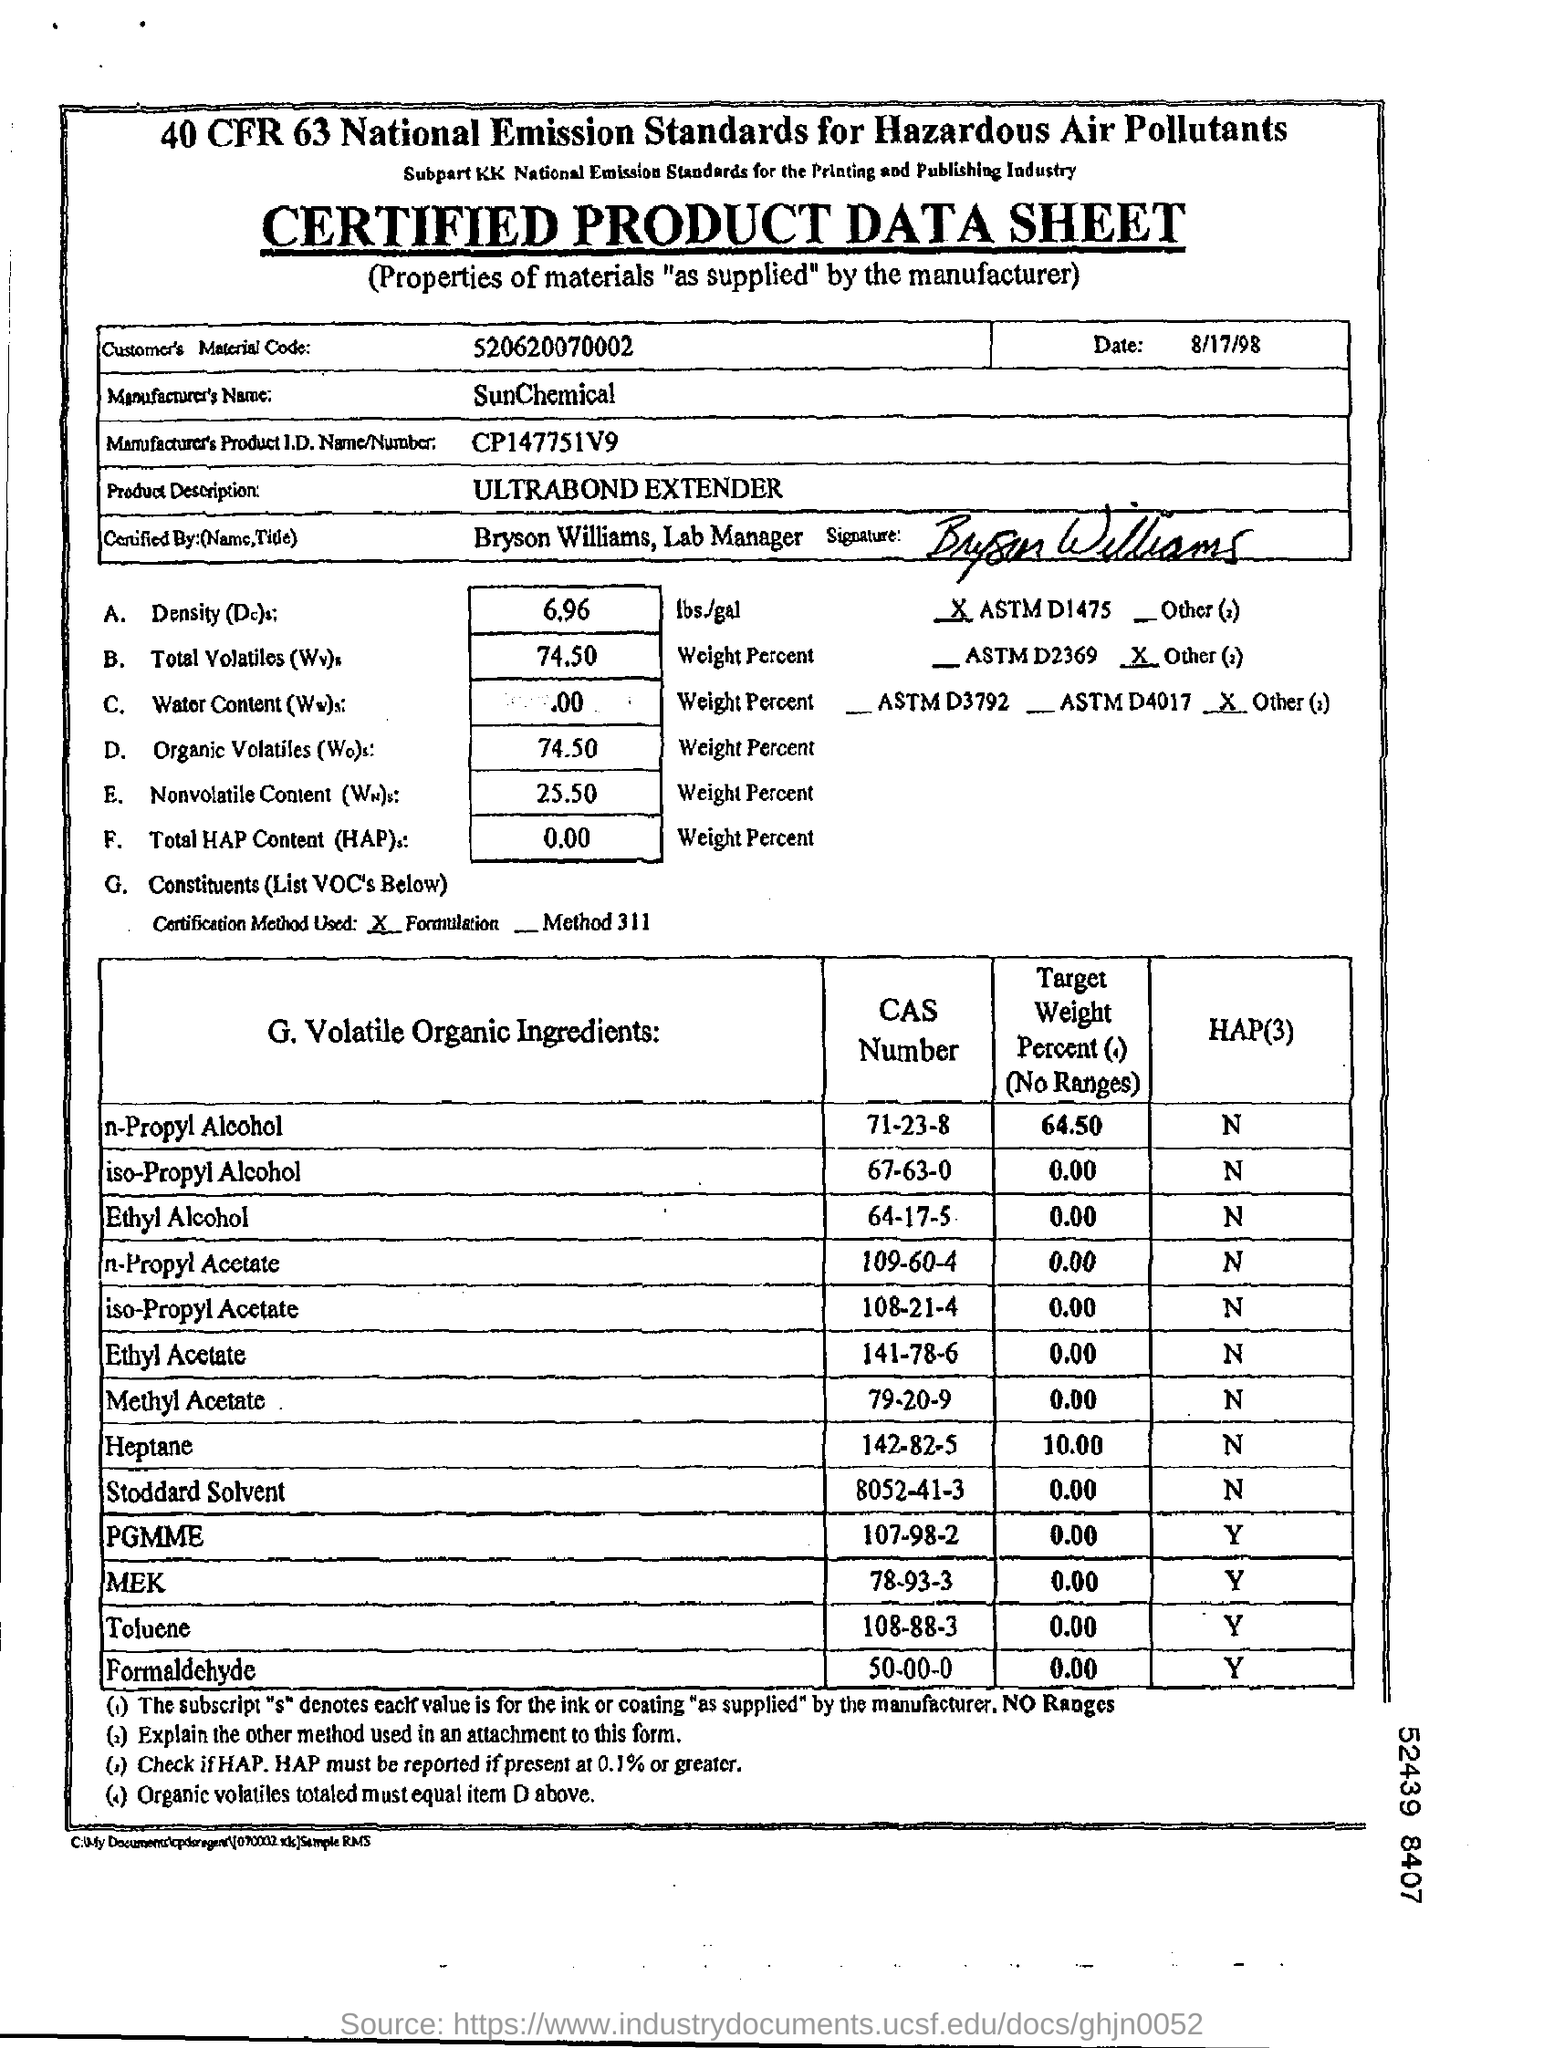Specify some key components in this picture. Ethyl alcohol, also known as grain alcohol or ethanol, has a CAS number of 64-17-5. The manufacturer's product identification number is CP147751V9. What is the name of the sheet? It is a certified product data sheet. The date mentioned at the top of the document is August 17, 1998. The customer's material code is 520620070002, consisting of 13 digits. 